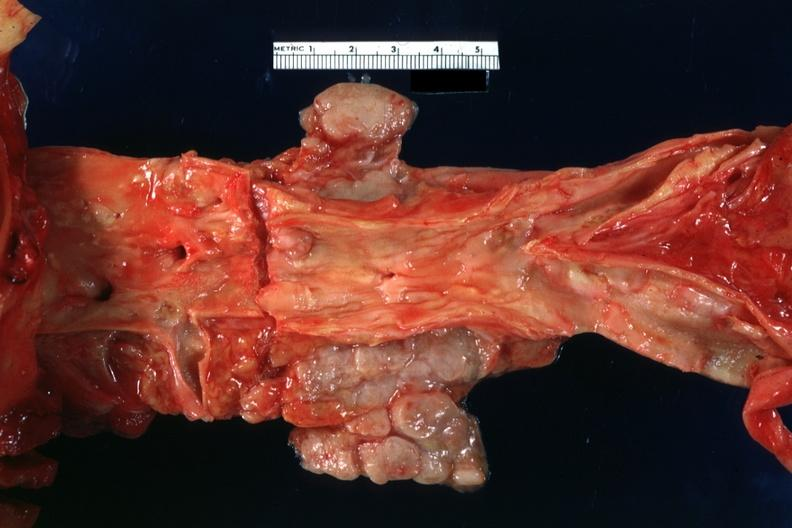what does periaortic nodes with metastatic carcinoma aorta show?
Answer the question using a single word or phrase. Good atherosclerotic plaques 